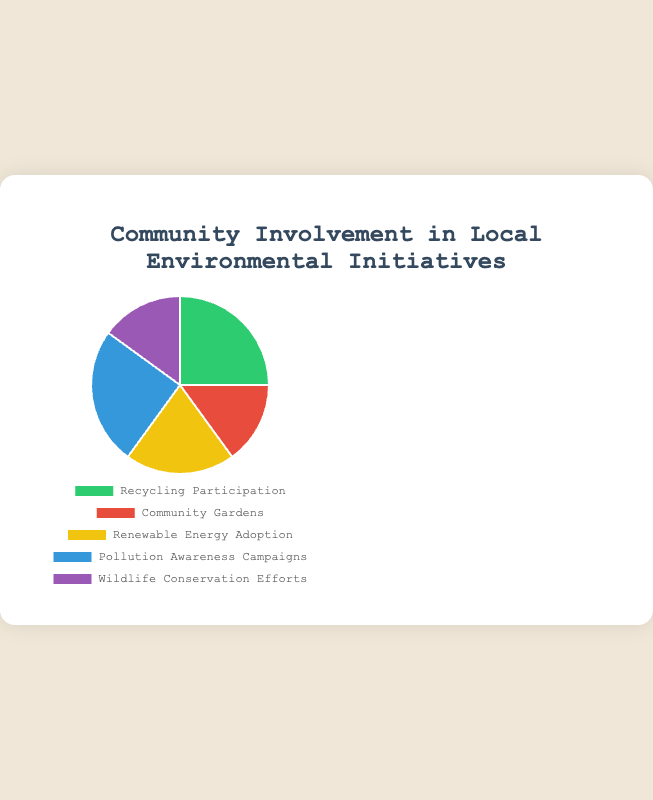what percentage of the initiatives are focused on "Recycling Participation" and "Pollution Awareness Campaigns" combined? First, observe that both "Recycling Participation" and "Pollution Awareness Campaigns" have 25%. Summing them up: 25% + 25% = 50%.
Answer: 50% Which environmental initiative received the least community involvement? By looking at the pie chart, "Community Gardens" and "Wildlife Conservation Efforts" both have the smallest slices, each representing 15%. Therefore, both received the least involvement.
Answer: Community Gardens and Wildlife Conservation Efforts Is the participation in "Renewable Energy Adoption" higher than "Community Gardens"? Observe that "Renewable Energy Adoption" has a higher percentage (20%) than "Community Gardens" (15%).
Answer: Yes How much greater is the involvement in "Recycling Participation" compared to "Community Gardens"? Calculate the difference between "Recycling Participation" (25%) and "Community Gardens" (15%): 25% - 15% = 10%.
Answer: 10% What is the second most involved initiative? The pie chart shows that the highest values are for "Recycling Participation" and "Pollution Awareness Campaigns" (both 25%). The next highest is "Renewable Energy Adoption" at 20%.
Answer: Renewable Energy Adoption 